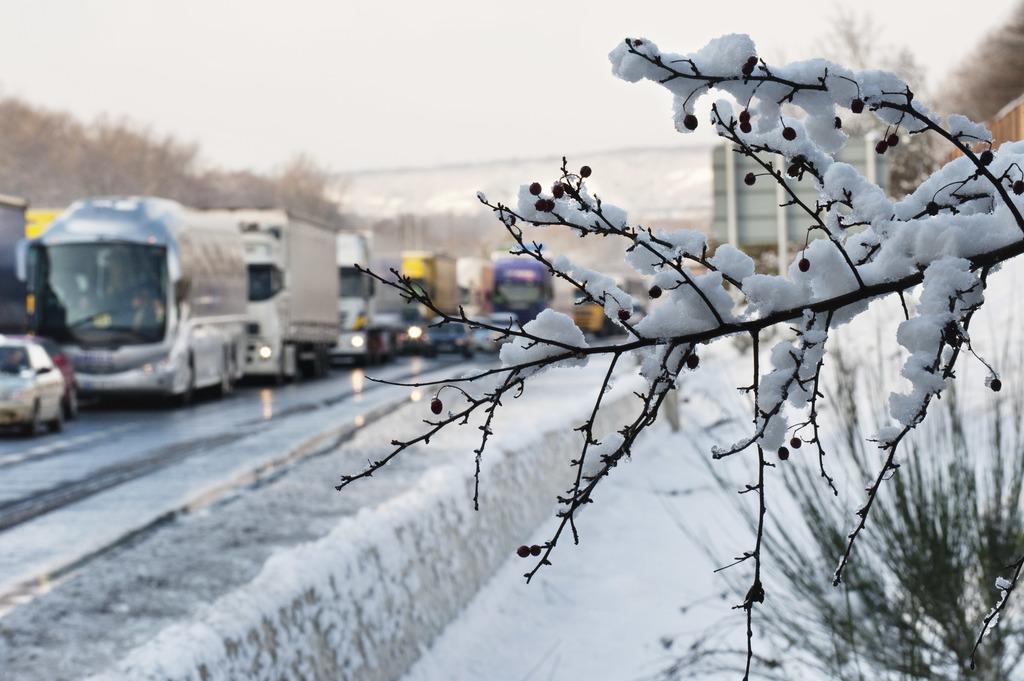In one or two sentences, can you explain what this image depicts? In this image in the foreground there is a tree and on the tree there is snow, and in the background there is snow, plant and some vehicles, trees and buildings. 